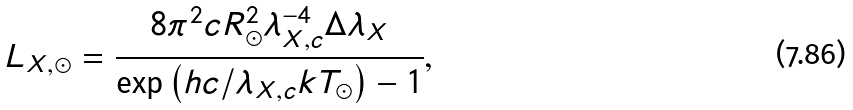<formula> <loc_0><loc_0><loc_500><loc_500>L _ { X , \odot } = \frac { 8 \pi ^ { 2 } c R ^ { 2 } _ { \odot } \lambda ^ { - 4 } _ { X , c } \Delta \lambda _ { X } } { \exp \left ( h c / \lambda _ { X , c } k T _ { \odot } \right ) - 1 } ,</formula> 